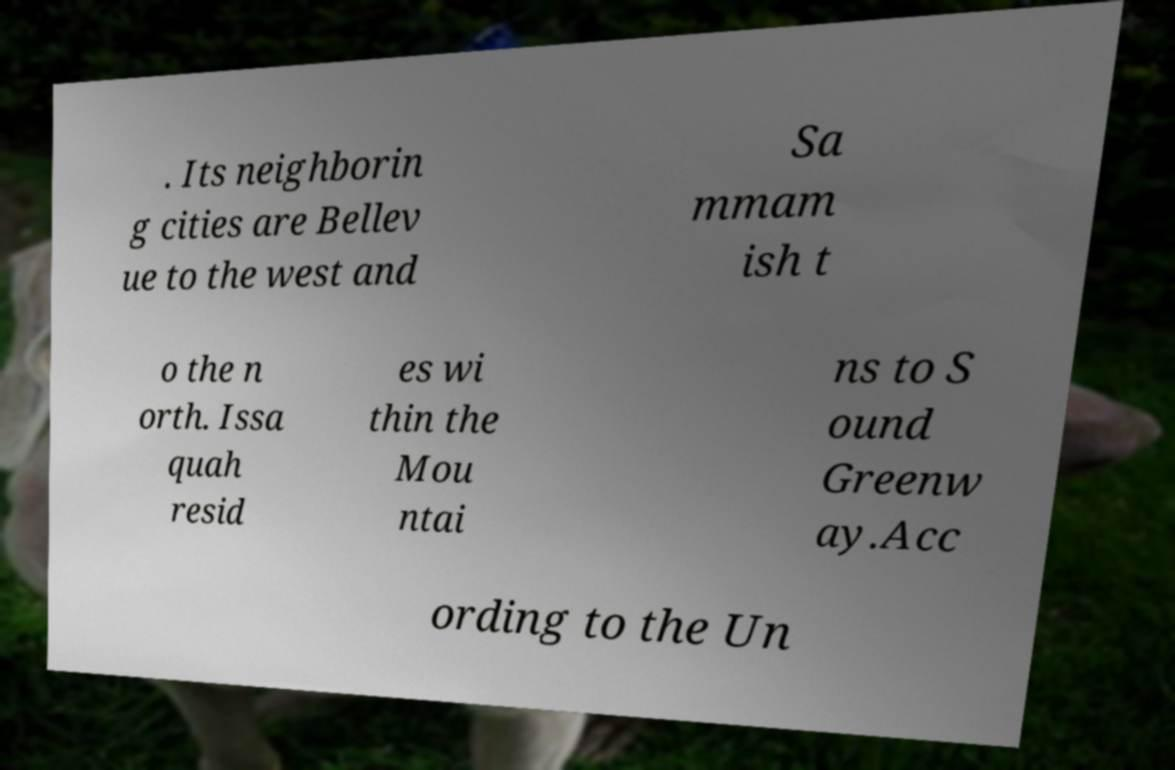Please identify and transcribe the text found in this image. . Its neighborin g cities are Bellev ue to the west and Sa mmam ish t o the n orth. Issa quah resid es wi thin the Mou ntai ns to S ound Greenw ay.Acc ording to the Un 